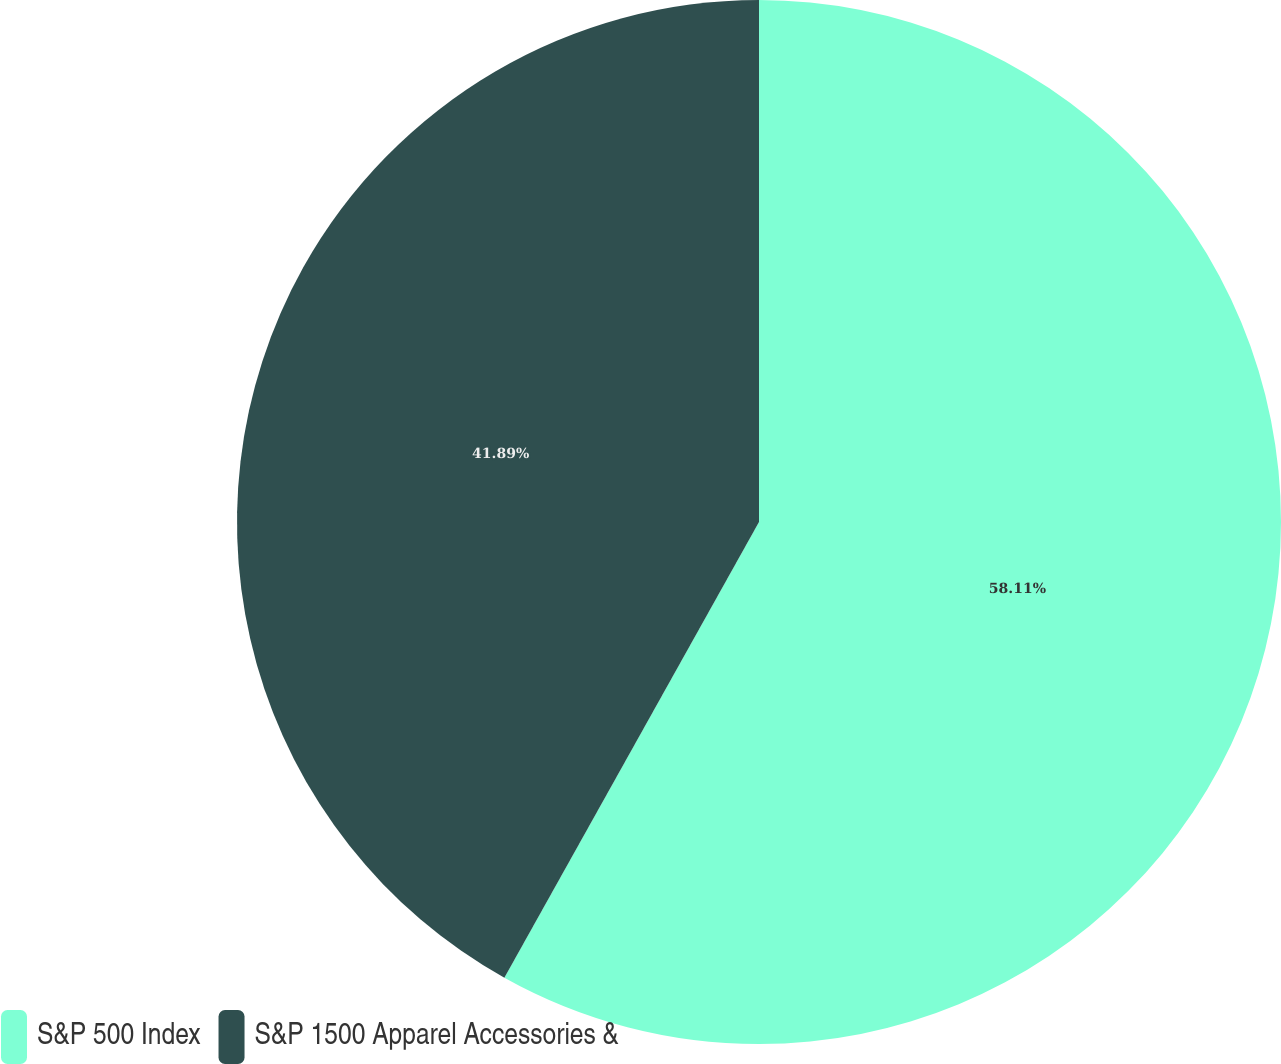Convert chart to OTSL. <chart><loc_0><loc_0><loc_500><loc_500><pie_chart><fcel>S&P 500 Index<fcel>S&P 1500 Apparel Accessories &<nl><fcel>58.11%<fcel>41.89%<nl></chart> 